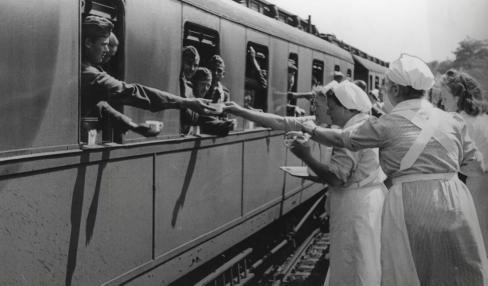Will the maids miss the passengers on the train?
Keep it brief. Yes. Is there a hill?
Quick response, please. No. Is this image in black and white?
Write a very short answer. Yes. 